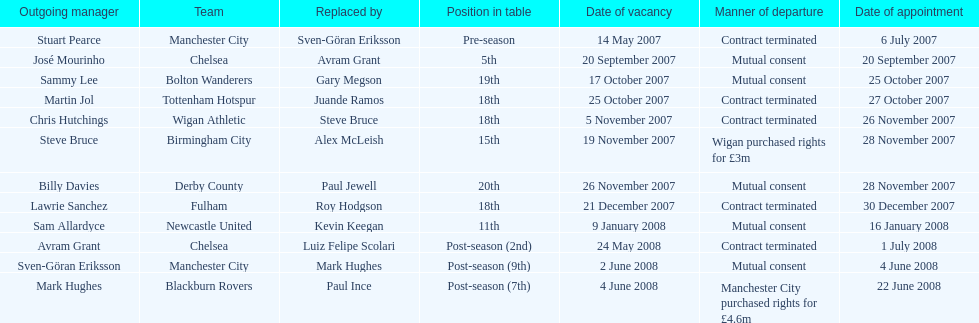Who was manager of manchester city after stuart pearce left in 2007? Sven-Göran Eriksson. 